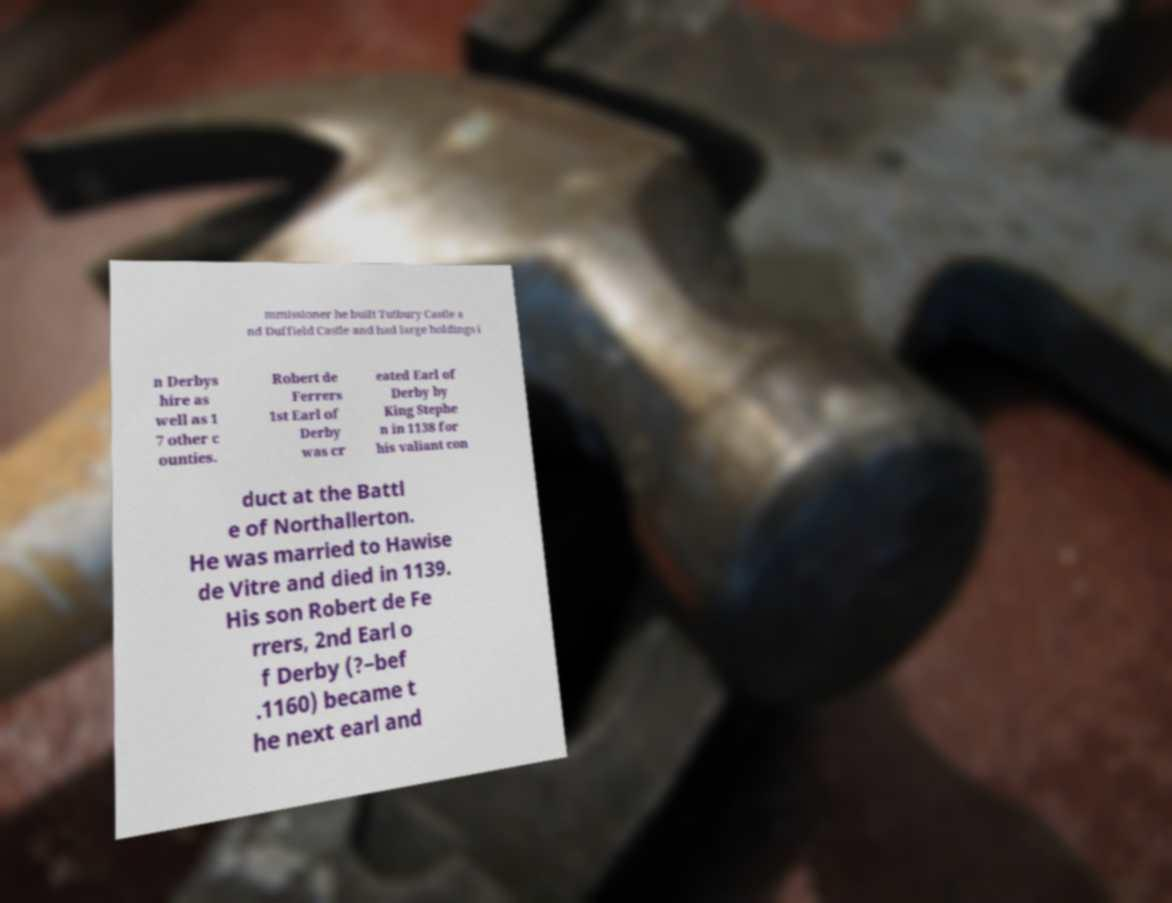Please read and relay the text visible in this image. What does it say? mmissioner he built Tutbury Castle a nd Duffield Castle and had large holdings i n Derbys hire as well as 1 7 other c ounties. Robert de Ferrers 1st Earl of Derby was cr eated Earl of Derby by King Stephe n in 1138 for his valiant con duct at the Battl e of Northallerton. He was married to Hawise de Vitre and died in 1139. His son Robert de Fe rrers, 2nd Earl o f Derby (?–bef .1160) became t he next earl and 